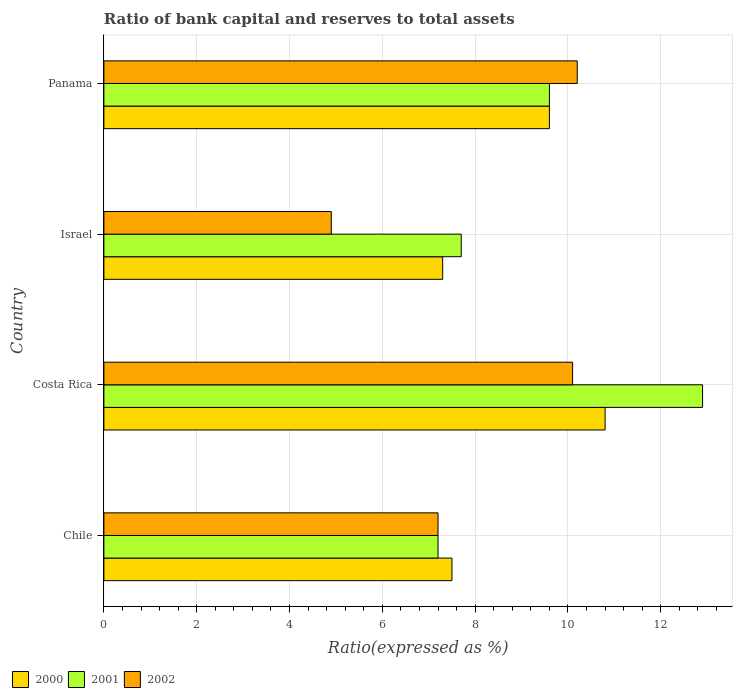How many bars are there on the 2nd tick from the top?
Provide a short and direct response. 3. What is the label of the 1st group of bars from the top?
Provide a short and direct response. Panama. In how many cases, is the number of bars for a given country not equal to the number of legend labels?
Make the answer very short. 0. Across all countries, what is the minimum ratio of bank capital and reserves to total assets in 2001?
Offer a terse response. 7.2. In which country was the ratio of bank capital and reserves to total assets in 2000 maximum?
Give a very brief answer. Costa Rica. In which country was the ratio of bank capital and reserves to total assets in 2001 minimum?
Your answer should be very brief. Chile. What is the total ratio of bank capital and reserves to total assets in 2001 in the graph?
Keep it short and to the point. 37.4. What is the difference between the ratio of bank capital and reserves to total assets in 2000 in Costa Rica and that in Israel?
Offer a terse response. 3.5. What is the difference between the ratio of bank capital and reserves to total assets in 2001 in Israel and the ratio of bank capital and reserves to total assets in 2000 in Panama?
Your response must be concise. -1.9. What is the difference between the ratio of bank capital and reserves to total assets in 2002 and ratio of bank capital and reserves to total assets in 2000 in Chile?
Provide a short and direct response. -0.3. What is the ratio of the ratio of bank capital and reserves to total assets in 2002 in Costa Rica to that in Panama?
Provide a short and direct response. 0.99. Is the difference between the ratio of bank capital and reserves to total assets in 2002 in Costa Rica and Israel greater than the difference between the ratio of bank capital and reserves to total assets in 2000 in Costa Rica and Israel?
Ensure brevity in your answer.  Yes. What is the difference between the highest and the second highest ratio of bank capital and reserves to total assets in 2002?
Provide a succinct answer. 0.1. In how many countries, is the ratio of bank capital and reserves to total assets in 2000 greater than the average ratio of bank capital and reserves to total assets in 2000 taken over all countries?
Offer a very short reply. 2. What does the 1st bar from the top in Chile represents?
Offer a very short reply. 2002. How many bars are there?
Your answer should be compact. 12. Are all the bars in the graph horizontal?
Your response must be concise. Yes. Does the graph contain any zero values?
Your response must be concise. No. Does the graph contain grids?
Give a very brief answer. Yes. How are the legend labels stacked?
Offer a terse response. Horizontal. What is the title of the graph?
Your response must be concise. Ratio of bank capital and reserves to total assets. Does "1966" appear as one of the legend labels in the graph?
Your answer should be very brief. No. What is the label or title of the X-axis?
Provide a short and direct response. Ratio(expressed as %). What is the label or title of the Y-axis?
Offer a very short reply. Country. What is the Ratio(expressed as %) of 2002 in Chile?
Offer a terse response. 7.2. What is the Ratio(expressed as %) of 2002 in Costa Rica?
Offer a terse response. 10.1. What is the Ratio(expressed as %) of 2002 in Israel?
Keep it short and to the point. 4.9. What is the Ratio(expressed as %) of 2000 in Panama?
Offer a very short reply. 9.6. What is the Ratio(expressed as %) of 2001 in Panama?
Your answer should be very brief. 9.6. Across all countries, what is the maximum Ratio(expressed as %) of 2001?
Your answer should be very brief. 12.9. Across all countries, what is the minimum Ratio(expressed as %) in 2000?
Your response must be concise. 7.3. Across all countries, what is the minimum Ratio(expressed as %) in 2001?
Ensure brevity in your answer.  7.2. Across all countries, what is the minimum Ratio(expressed as %) of 2002?
Your response must be concise. 4.9. What is the total Ratio(expressed as %) of 2000 in the graph?
Ensure brevity in your answer.  35.2. What is the total Ratio(expressed as %) in 2001 in the graph?
Offer a very short reply. 37.4. What is the total Ratio(expressed as %) of 2002 in the graph?
Your response must be concise. 32.4. What is the difference between the Ratio(expressed as %) of 2002 in Chile and that in Costa Rica?
Offer a very short reply. -2.9. What is the difference between the Ratio(expressed as %) of 2000 in Chile and that in Panama?
Your answer should be very brief. -2.1. What is the difference between the Ratio(expressed as %) of 2000 in Costa Rica and that in Israel?
Offer a terse response. 3.5. What is the difference between the Ratio(expressed as %) in 2001 in Costa Rica and that in Israel?
Make the answer very short. 5.2. What is the difference between the Ratio(expressed as %) of 2002 in Costa Rica and that in Israel?
Keep it short and to the point. 5.2. What is the difference between the Ratio(expressed as %) of 2000 in Costa Rica and that in Panama?
Keep it short and to the point. 1.2. What is the difference between the Ratio(expressed as %) of 2001 in Costa Rica and that in Panama?
Your response must be concise. 3.3. What is the difference between the Ratio(expressed as %) in 2002 in Costa Rica and that in Panama?
Make the answer very short. -0.1. What is the difference between the Ratio(expressed as %) of 2000 in Israel and that in Panama?
Offer a very short reply. -2.3. What is the difference between the Ratio(expressed as %) of 2001 in Israel and that in Panama?
Your response must be concise. -1.9. What is the difference between the Ratio(expressed as %) of 2000 in Chile and the Ratio(expressed as %) of 2002 in Costa Rica?
Provide a short and direct response. -2.6. What is the difference between the Ratio(expressed as %) in 2001 in Chile and the Ratio(expressed as %) in 2002 in Costa Rica?
Ensure brevity in your answer.  -2.9. What is the difference between the Ratio(expressed as %) of 2000 in Chile and the Ratio(expressed as %) of 2001 in Israel?
Your answer should be very brief. -0.2. What is the difference between the Ratio(expressed as %) in 2001 in Chile and the Ratio(expressed as %) in 2002 in Panama?
Provide a short and direct response. -3. What is the difference between the Ratio(expressed as %) in 2000 in Costa Rica and the Ratio(expressed as %) in 2002 in Israel?
Your response must be concise. 5.9. What is the difference between the Ratio(expressed as %) of 2000 in Costa Rica and the Ratio(expressed as %) of 2001 in Panama?
Make the answer very short. 1.2. What is the difference between the Ratio(expressed as %) in 2000 in Costa Rica and the Ratio(expressed as %) in 2002 in Panama?
Keep it short and to the point. 0.6. What is the difference between the Ratio(expressed as %) of 2001 in Costa Rica and the Ratio(expressed as %) of 2002 in Panama?
Provide a succinct answer. 2.7. What is the difference between the Ratio(expressed as %) in 2000 in Israel and the Ratio(expressed as %) in 2001 in Panama?
Your response must be concise. -2.3. What is the difference between the Ratio(expressed as %) in 2000 in Israel and the Ratio(expressed as %) in 2002 in Panama?
Ensure brevity in your answer.  -2.9. What is the average Ratio(expressed as %) of 2001 per country?
Provide a short and direct response. 9.35. What is the average Ratio(expressed as %) of 2002 per country?
Your response must be concise. 8.1. What is the difference between the Ratio(expressed as %) in 2000 and Ratio(expressed as %) in 2002 in Chile?
Your answer should be very brief. 0.3. What is the difference between the Ratio(expressed as %) in 2001 and Ratio(expressed as %) in 2002 in Costa Rica?
Make the answer very short. 2.8. What is the difference between the Ratio(expressed as %) in 2000 and Ratio(expressed as %) in 2001 in Israel?
Give a very brief answer. -0.4. What is the difference between the Ratio(expressed as %) in 2001 and Ratio(expressed as %) in 2002 in Israel?
Offer a very short reply. 2.8. What is the difference between the Ratio(expressed as %) in 2000 and Ratio(expressed as %) in 2001 in Panama?
Your answer should be compact. 0. What is the difference between the Ratio(expressed as %) in 2001 and Ratio(expressed as %) in 2002 in Panama?
Your answer should be very brief. -0.6. What is the ratio of the Ratio(expressed as %) of 2000 in Chile to that in Costa Rica?
Ensure brevity in your answer.  0.69. What is the ratio of the Ratio(expressed as %) in 2001 in Chile to that in Costa Rica?
Make the answer very short. 0.56. What is the ratio of the Ratio(expressed as %) of 2002 in Chile to that in Costa Rica?
Ensure brevity in your answer.  0.71. What is the ratio of the Ratio(expressed as %) in 2000 in Chile to that in Israel?
Your answer should be compact. 1.03. What is the ratio of the Ratio(expressed as %) in 2001 in Chile to that in Israel?
Ensure brevity in your answer.  0.94. What is the ratio of the Ratio(expressed as %) in 2002 in Chile to that in Israel?
Give a very brief answer. 1.47. What is the ratio of the Ratio(expressed as %) of 2000 in Chile to that in Panama?
Offer a terse response. 0.78. What is the ratio of the Ratio(expressed as %) of 2002 in Chile to that in Panama?
Make the answer very short. 0.71. What is the ratio of the Ratio(expressed as %) of 2000 in Costa Rica to that in Israel?
Give a very brief answer. 1.48. What is the ratio of the Ratio(expressed as %) of 2001 in Costa Rica to that in Israel?
Provide a succinct answer. 1.68. What is the ratio of the Ratio(expressed as %) in 2002 in Costa Rica to that in Israel?
Offer a terse response. 2.06. What is the ratio of the Ratio(expressed as %) in 2000 in Costa Rica to that in Panama?
Give a very brief answer. 1.12. What is the ratio of the Ratio(expressed as %) of 2001 in Costa Rica to that in Panama?
Keep it short and to the point. 1.34. What is the ratio of the Ratio(expressed as %) of 2002 in Costa Rica to that in Panama?
Your response must be concise. 0.99. What is the ratio of the Ratio(expressed as %) of 2000 in Israel to that in Panama?
Make the answer very short. 0.76. What is the ratio of the Ratio(expressed as %) in 2001 in Israel to that in Panama?
Provide a short and direct response. 0.8. What is the ratio of the Ratio(expressed as %) in 2002 in Israel to that in Panama?
Offer a terse response. 0.48. What is the difference between the highest and the second highest Ratio(expressed as %) in 2002?
Offer a terse response. 0.1. What is the difference between the highest and the lowest Ratio(expressed as %) in 2000?
Give a very brief answer. 3.5. 